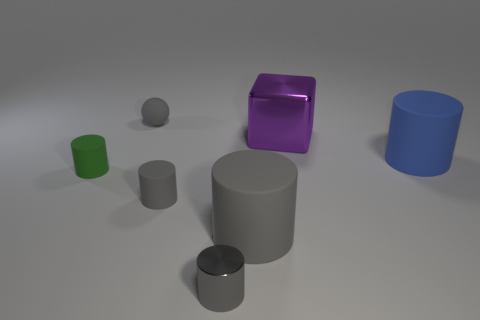Subtract all gray cylinders. How many were subtracted if there are1gray cylinders left? 2 Subtract all metal cylinders. How many cylinders are left? 4 Subtract all brown blocks. How many gray cylinders are left? 3 Subtract all blue cylinders. How many cylinders are left? 4 Subtract all blue cylinders. Subtract all purple spheres. How many cylinders are left? 4 Add 1 small gray things. How many objects exist? 8 Subtract all spheres. How many objects are left? 6 Subtract 0 purple cylinders. How many objects are left? 7 Subtract all large blue cylinders. Subtract all small gray cylinders. How many objects are left? 4 Add 6 green cylinders. How many green cylinders are left? 7 